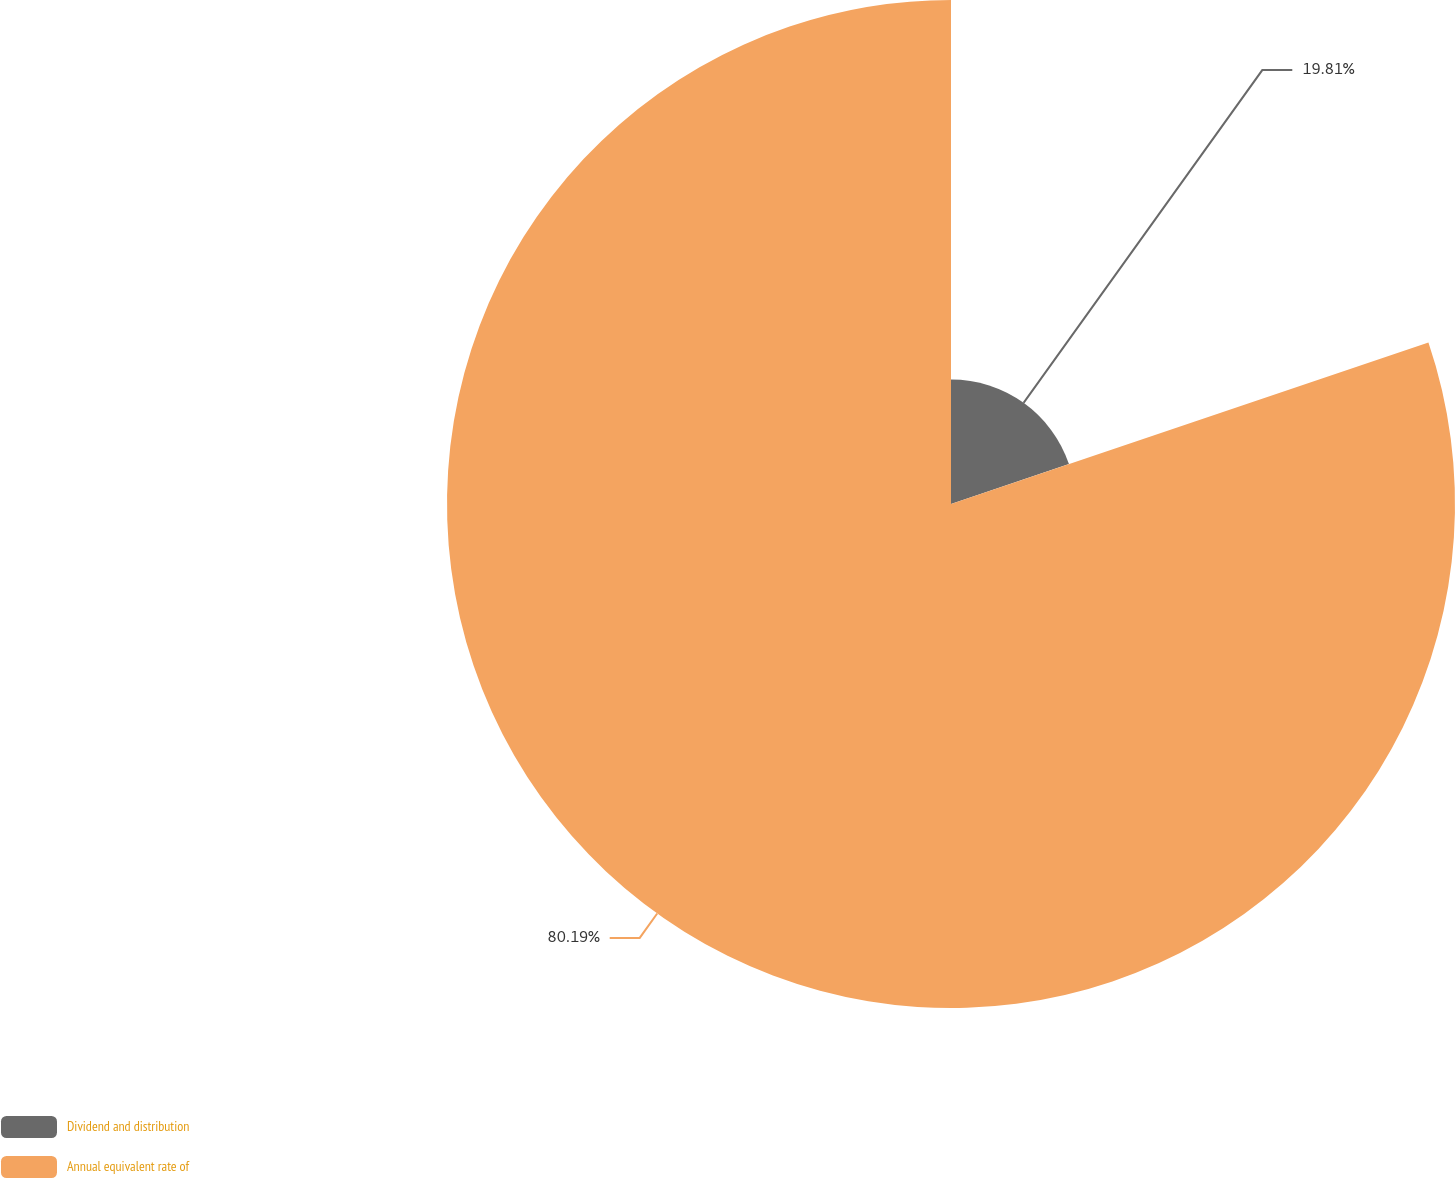Convert chart. <chart><loc_0><loc_0><loc_500><loc_500><pie_chart><fcel>Dividend and distribution<fcel>Annual equivalent rate of<nl><fcel>19.81%<fcel>80.19%<nl></chart> 